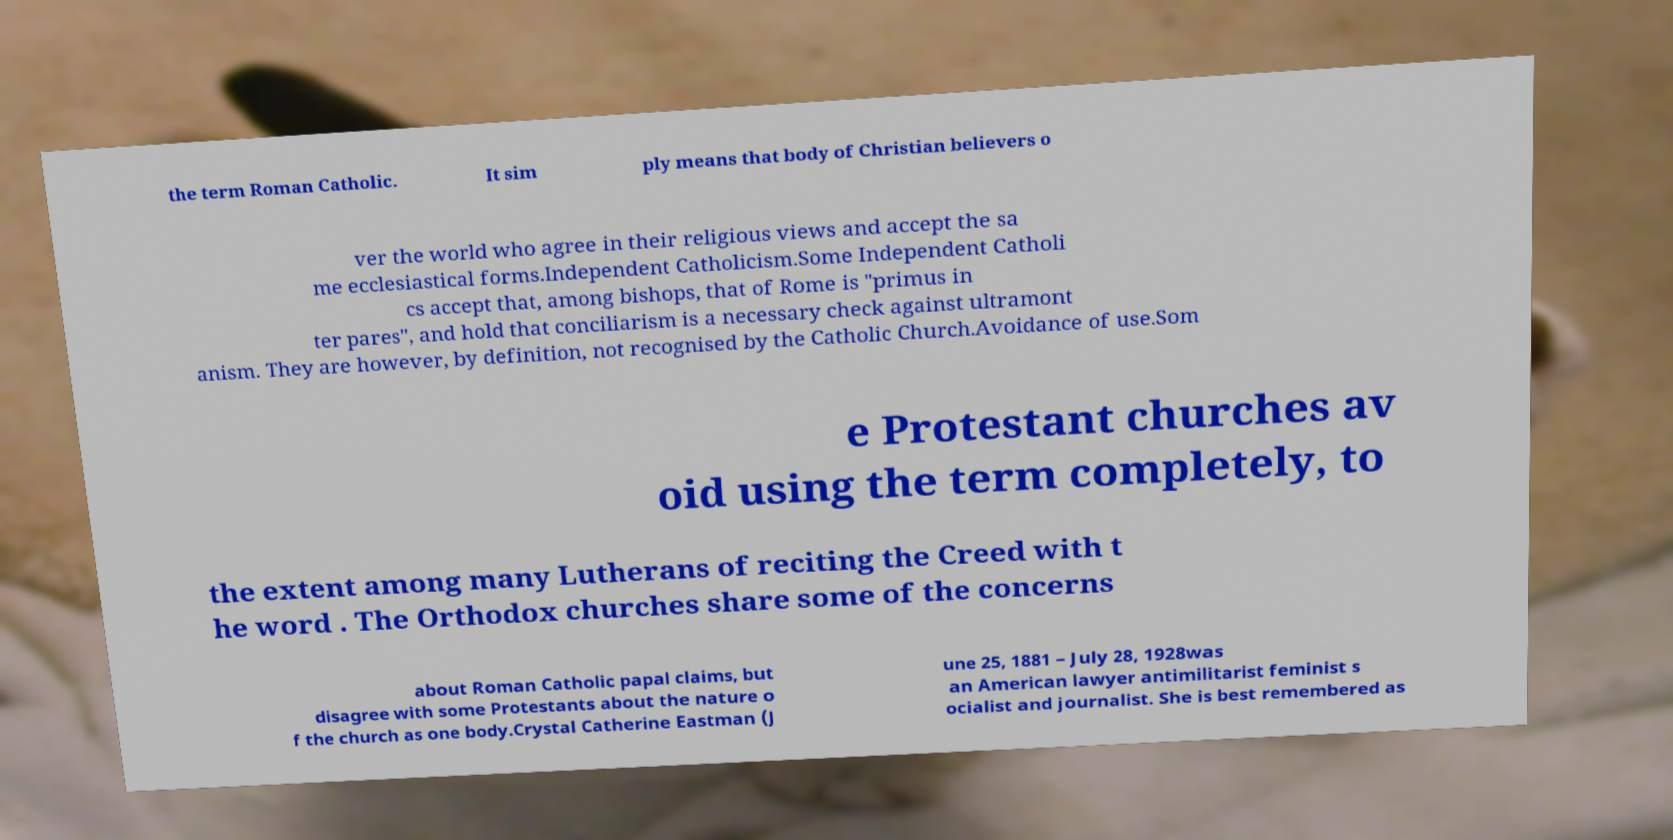Could you extract and type out the text from this image? the term Roman Catholic. It sim ply means that body of Christian believers o ver the world who agree in their religious views and accept the sa me ecclesiastical forms.Independent Catholicism.Some Independent Catholi cs accept that, among bishops, that of Rome is "primus in ter pares", and hold that conciliarism is a necessary check against ultramont anism. They are however, by definition, not recognised by the Catholic Church.Avoidance of use.Som e Protestant churches av oid using the term completely, to the extent among many Lutherans of reciting the Creed with t he word . The Orthodox churches share some of the concerns about Roman Catholic papal claims, but disagree with some Protestants about the nature o f the church as one body.Crystal Catherine Eastman (J une 25, 1881 – July 28, 1928was an American lawyer antimilitarist feminist s ocialist and journalist. She is best remembered as 